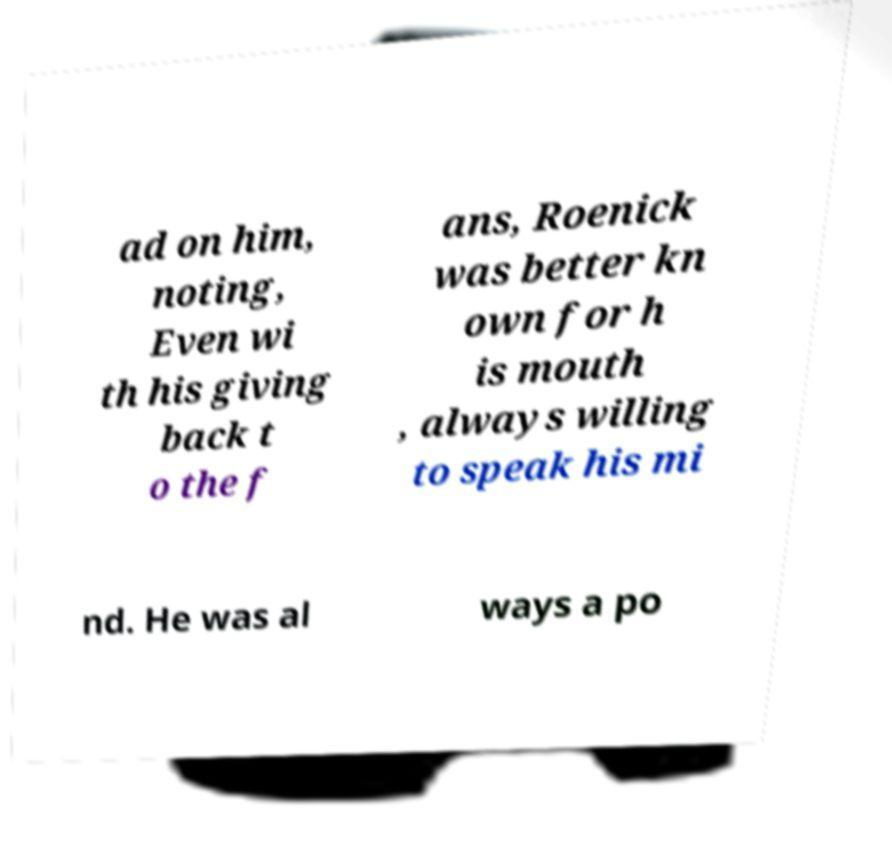Could you assist in decoding the text presented in this image and type it out clearly? ad on him, noting, Even wi th his giving back t o the f ans, Roenick was better kn own for h is mouth , always willing to speak his mi nd. He was al ways a po 